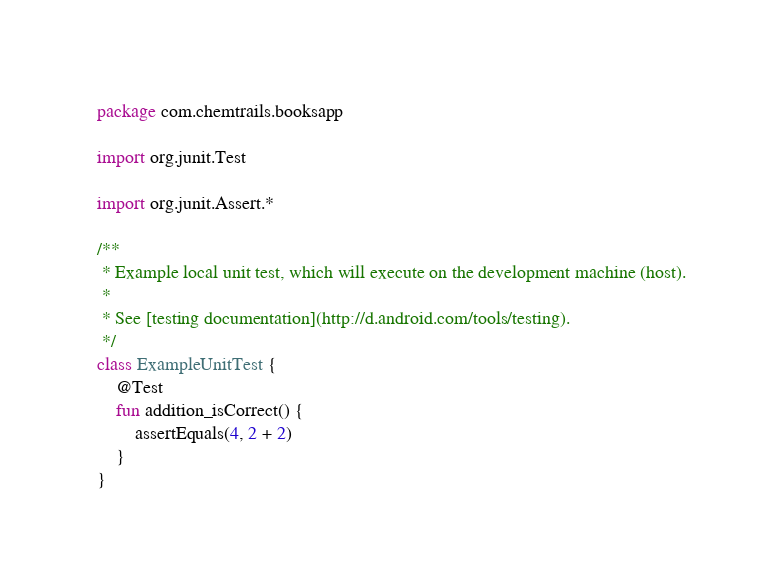<code> <loc_0><loc_0><loc_500><loc_500><_Kotlin_>package com.chemtrails.booksapp

import org.junit.Test

import org.junit.Assert.*

/**
 * Example local unit test, which will execute on the development machine (host).
 *
 * See [testing documentation](http://d.android.com/tools/testing).
 */
class ExampleUnitTest {
    @Test
    fun addition_isCorrect() {
        assertEquals(4, 2 + 2)
    }
}</code> 